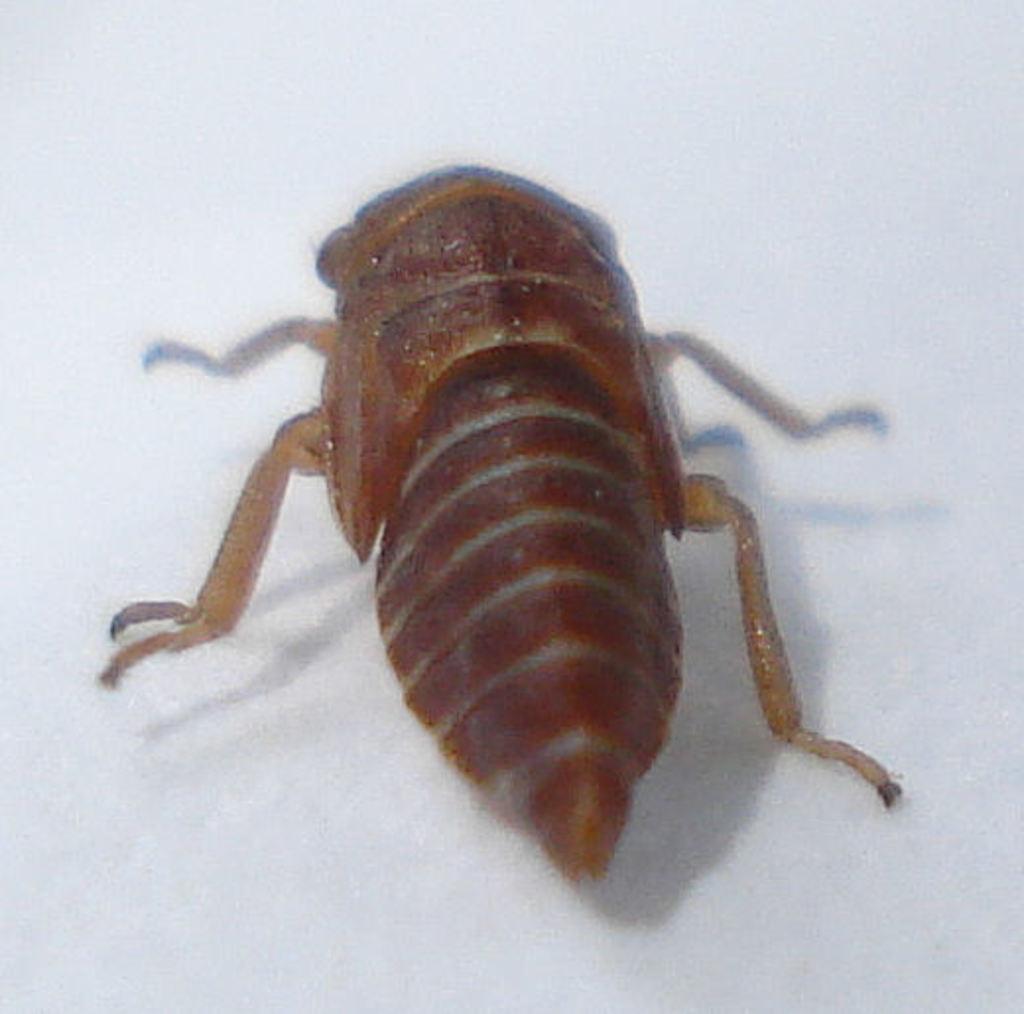Please provide a concise description of this image. In this picture I can see an insect which is of brown color and it is on the white color surface. 